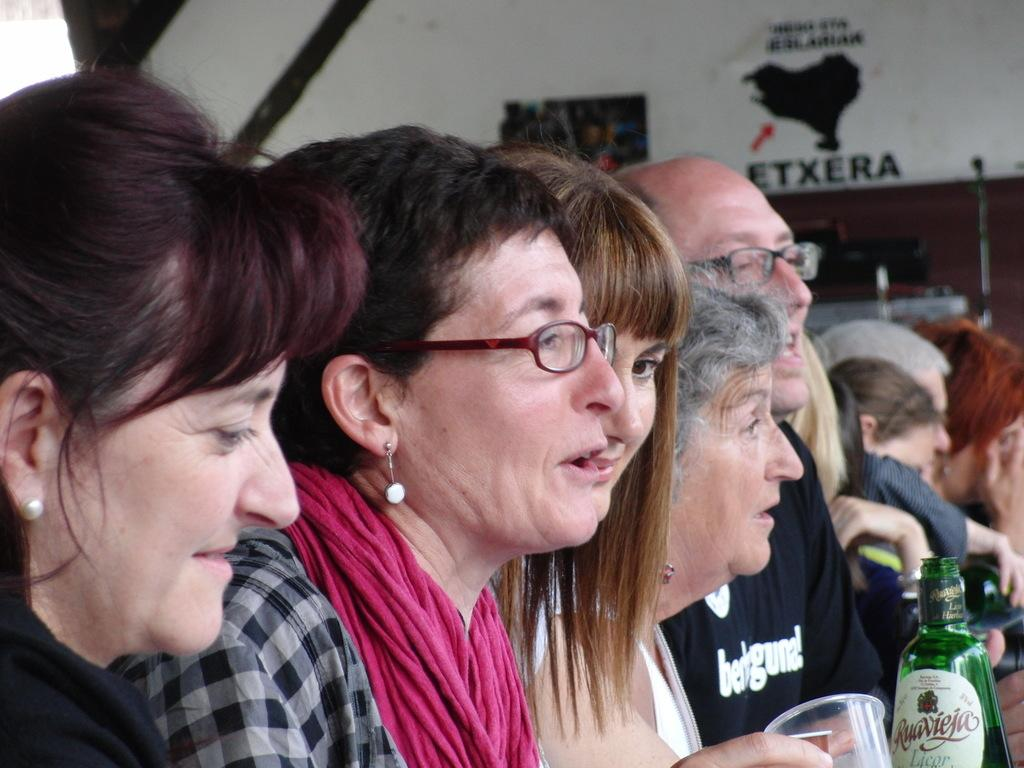How many people are in the group that is visible in the image? There is a group of people in the image, but the exact number is not specified. What is the facial expression of the people in the group? The people in the group are smiling. What type of object is the glass bottle in the image? The fact does not specify the contents or purpose of the glass bottle. Can you tell me how many zebras are present in the image? There are no zebras present in the image; it features a group of people and a glass bottle. What type of cheese is being measured in the image? There is no cheese or measuring activity present in the image. 